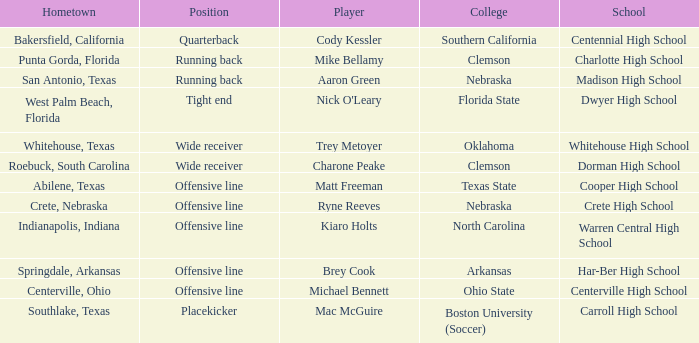What was the position of the player that went to warren central high school? Offensive line. 